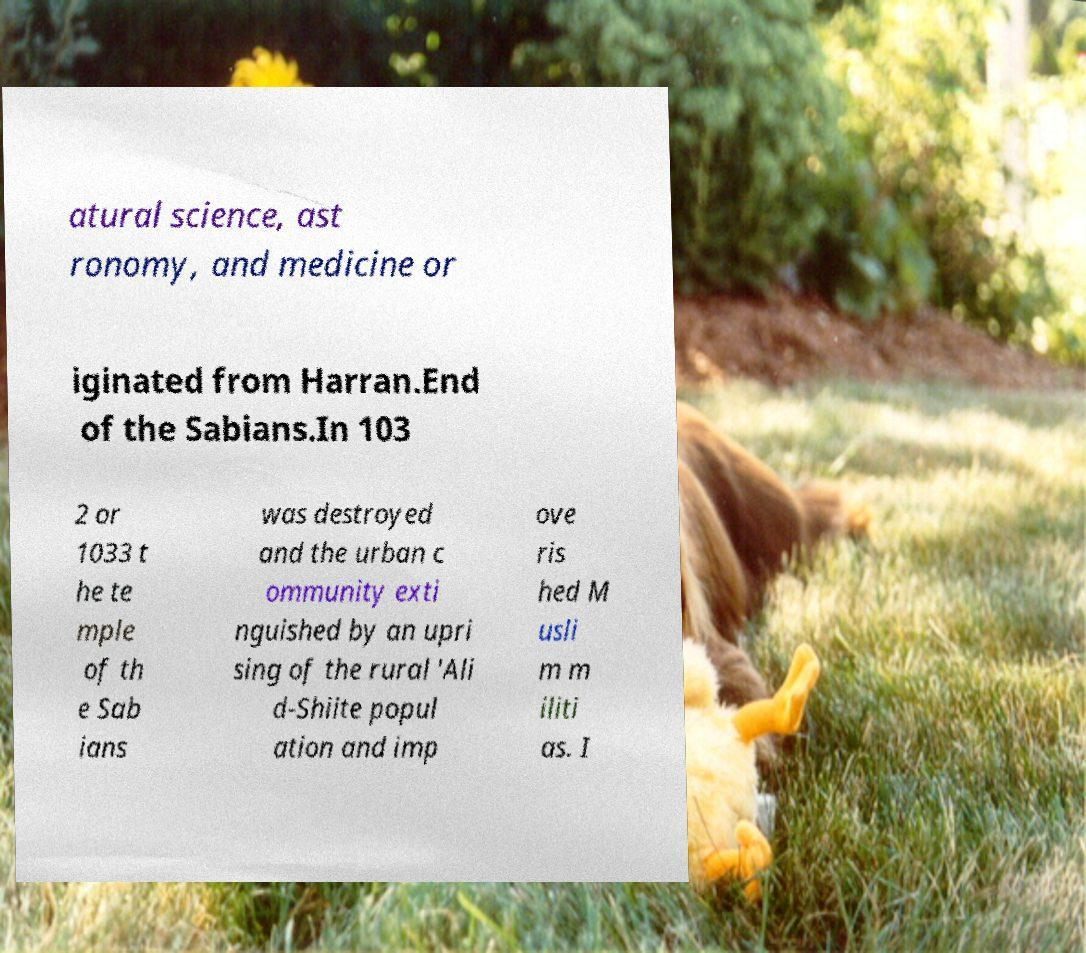Can you read and provide the text displayed in the image?This photo seems to have some interesting text. Can you extract and type it out for me? atural science, ast ronomy, and medicine or iginated from Harran.End of the Sabians.In 103 2 or 1033 t he te mple of th e Sab ians was destroyed and the urban c ommunity exti nguished by an upri sing of the rural 'Ali d-Shiite popul ation and imp ove ris hed M usli m m iliti as. I 